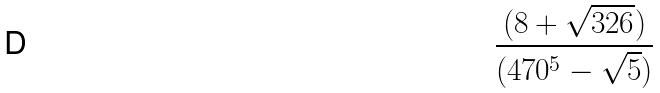<formula> <loc_0><loc_0><loc_500><loc_500>\frac { ( 8 + \sqrt { 3 2 6 } ) } { ( 4 7 0 ^ { 5 } - \sqrt { 5 } ) }</formula> 